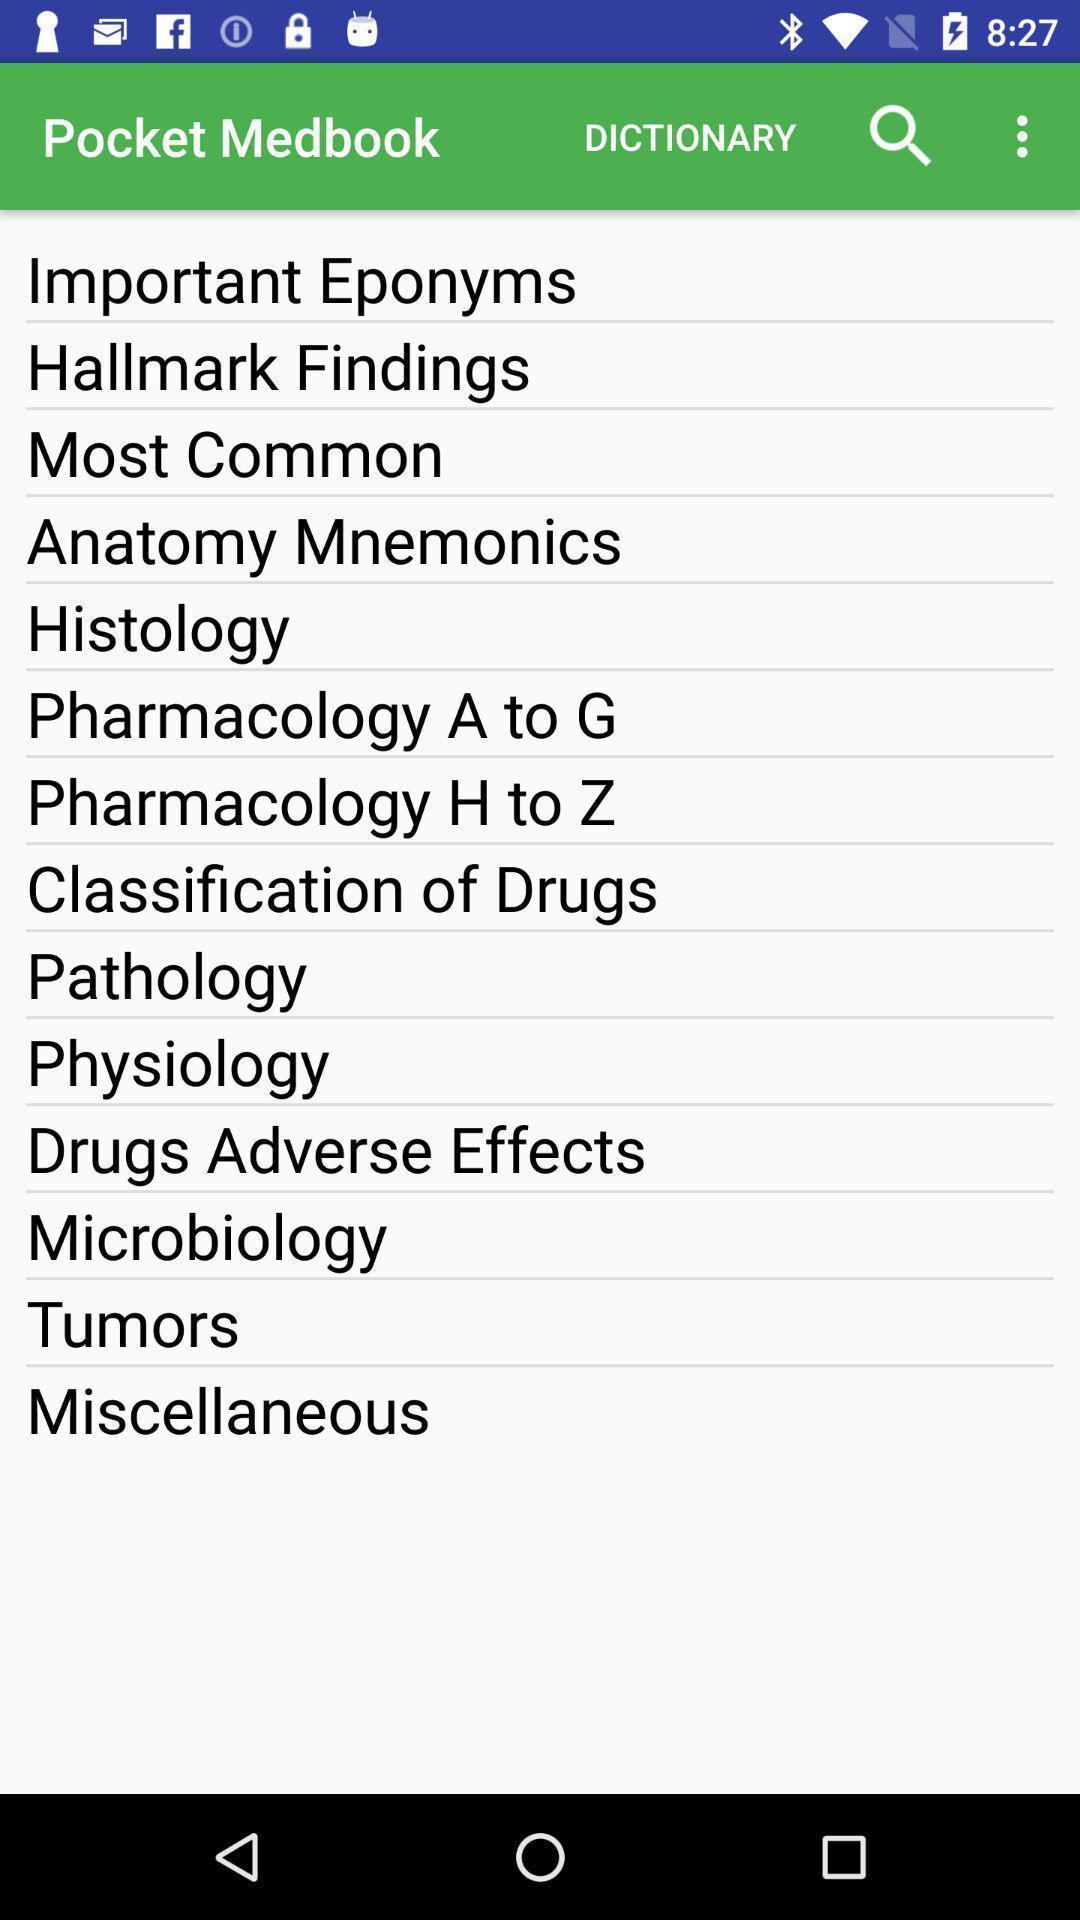Explain the elements present in this screenshot. Screen displaying the page of review app for medical students. 